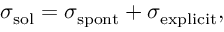<formula> <loc_0><loc_0><loc_500><loc_500>\sigma _ { s o l } = \sigma _ { s p o n t } + \sigma _ { e x p l i c i t } ,</formula> 